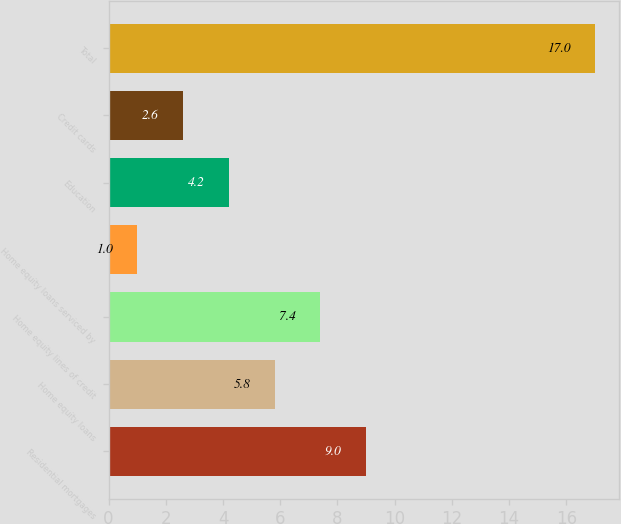<chart> <loc_0><loc_0><loc_500><loc_500><bar_chart><fcel>Residential mortgages<fcel>Home equity loans<fcel>Home equity lines of credit<fcel>Home equity loans serviced by<fcel>Education<fcel>Credit cards<fcel>Total<nl><fcel>9<fcel>5.8<fcel>7.4<fcel>1<fcel>4.2<fcel>2.6<fcel>17<nl></chart> 